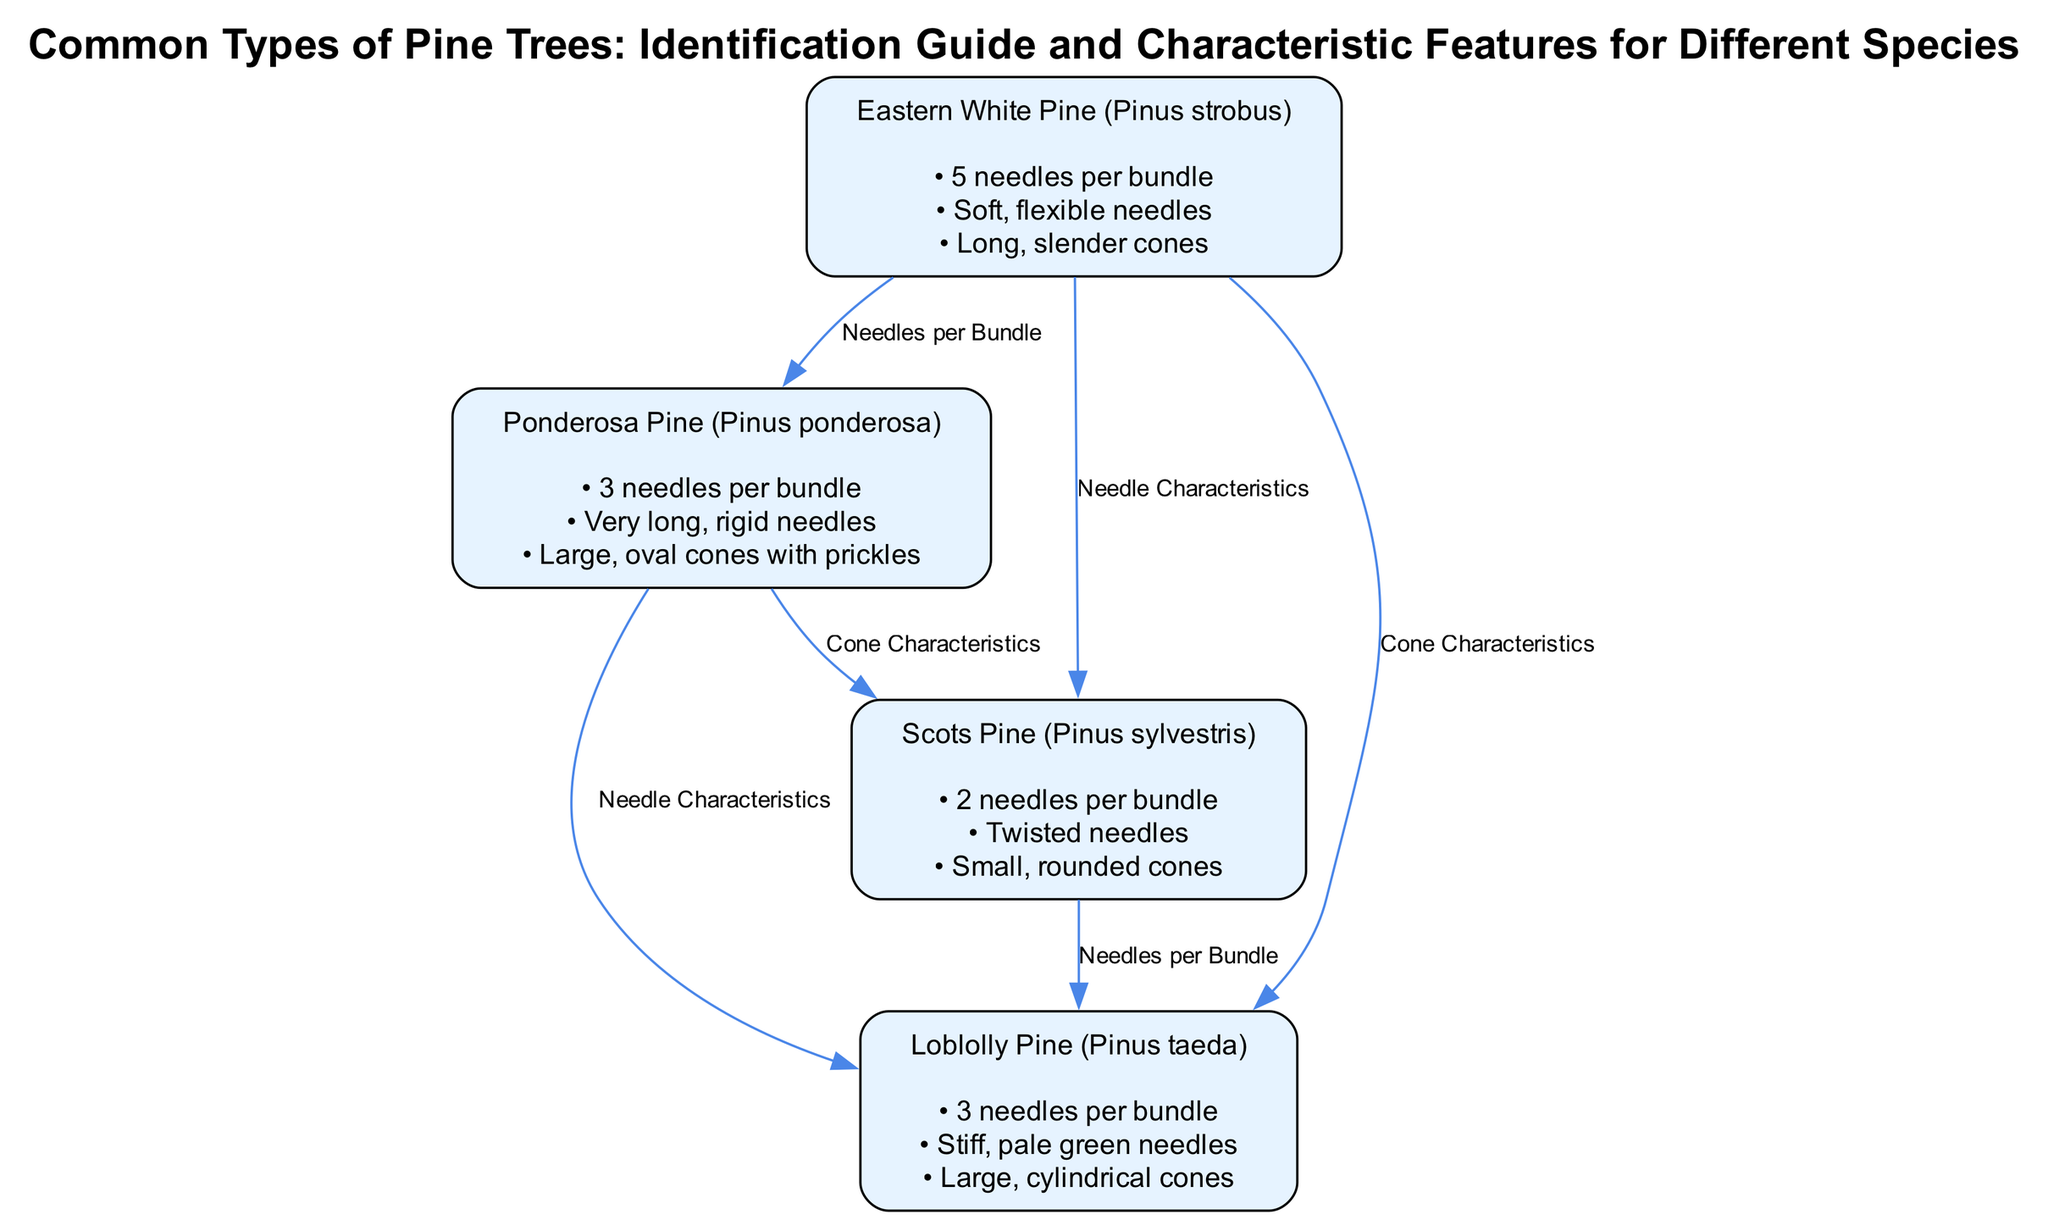What is the number of nodes in the diagram? The diagram lists four types of pine trees as nodes: Eastern White Pine, Ponderosa Pine, Scots Pine, and Loblolly Pine. Therefore, counting these gives us a total of four nodes.
Answer: 4 How many edges are there connecting the nodes? The diagram depicts six edges that represent relationships between the different pine tree species. Each relationship between two nodes corresponds to one edge, which totals up to six.
Answer: 6 What are the needle characteristics of Eastern White Pine? The diagram specifies that the Eastern White Pine has "soft, flexible needles." This characteristic is listed under the respective node for Eastern White Pine.
Answer: Soft, flexible needles Which tree has 3 needles per bundle? According to the diagram, both Ponderosa Pine and Loblolly Pine feature "3 needles per bundle." This means either of these two trees could be an answer, but both are listed together under the respective nodes.
Answer: Ponderosa Pine, Loblolly Pine What type of cone does Scots Pine have? The diagram mentions that Scots Pine has "small, rounded cones." This is clearly indicated within the node for the Scots Pine species.
Answer: Small, rounded cones Which tree species has twisted needles? The diagram indicates that the Scots Pine is characterized by "twisted needles," clearly shown in the characteristics listed under the Scots Pine node.
Answer: Scots Pine Are the cones of Eastern White Pine long or cylindrical? The diagram describes the cones of Eastern White Pine as "long, slender cones," directly stating this characteristic for the Eastern White Pine node.
Answer: Long, slender cones If you have a tree with stiff, pale green needles, what species is it? The diagram specifies that stiff, pale green needles are characteristic of Loblolly Pine. This information is found directly under the respective node for Loblolly Pine.
Answer: Loblolly Pine What relationship does Loblolly Pine have with Eastern White Pine? The diagram shows that there is a relationship identified as "Cone Characteristics" between Loblolly Pine and Eastern White Pine, indicating a connection based on their cones.
Answer: Cone Characteristics 